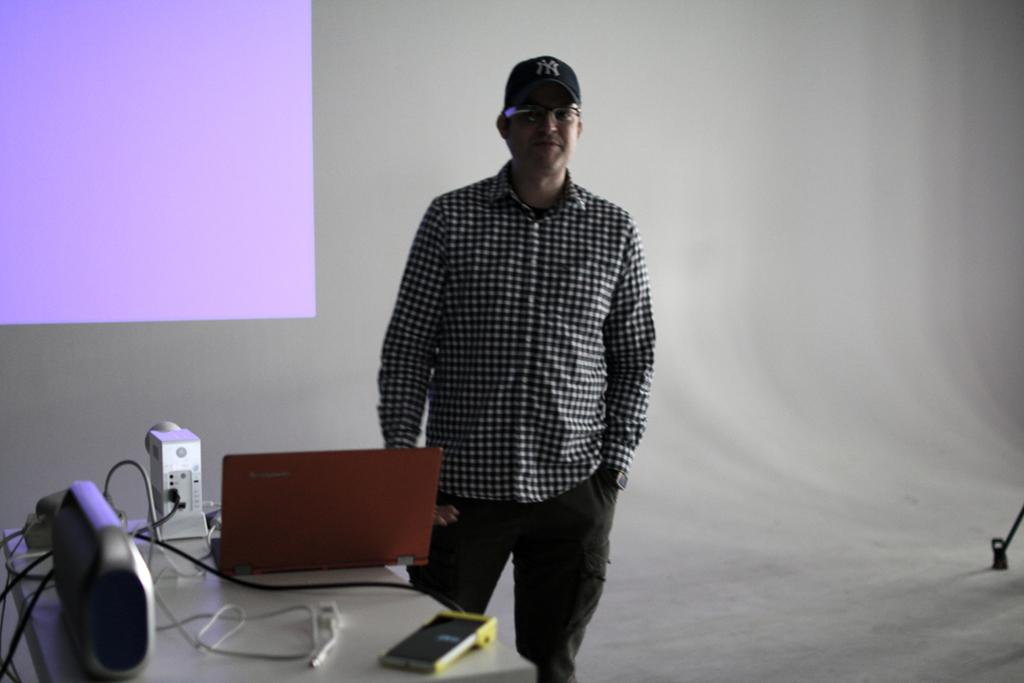What is the man doing in the image? The man is standing beside the table in the image. What can be seen on the table? There are gadgets on the table in the image. What is the color of the screen behind the man? The screen behind the man is purple. Can you see any glue on the table in the image? There is no mention of glue in the image, so it cannot be determined if it is present or not. 